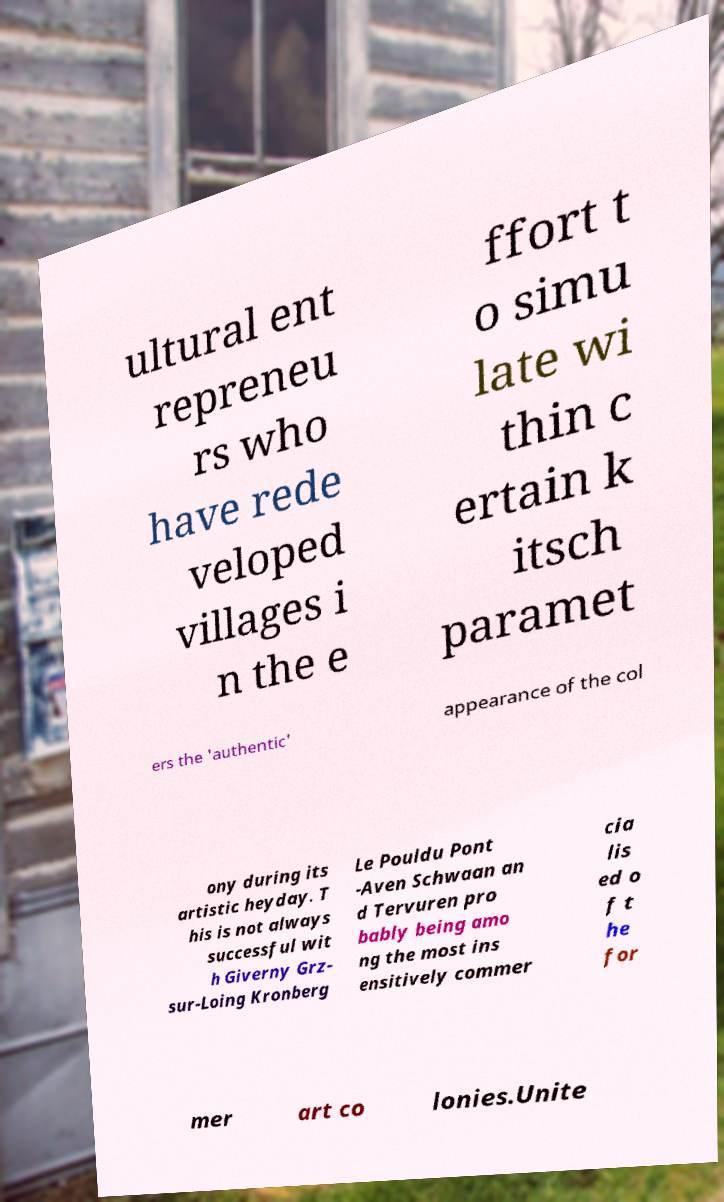Could you extract and type out the text from this image? ultural ent repreneu rs who have rede veloped villages i n the e ffort t o simu late wi thin c ertain k itsch paramet ers the 'authentic' appearance of the col ony during its artistic heyday. T his is not always successful wit h Giverny Grz- sur-Loing Kronberg Le Pouldu Pont -Aven Schwaan an d Tervuren pro bably being amo ng the most ins ensitively commer cia lis ed o f t he for mer art co lonies.Unite 